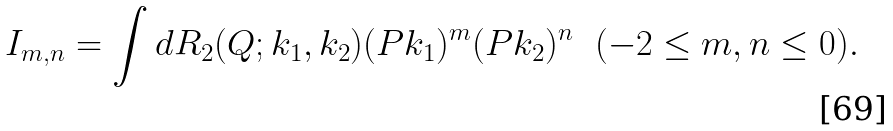Convert formula to latex. <formula><loc_0><loc_0><loc_500><loc_500>I _ { m , n } = \int d R _ { 2 } ( Q ; k _ { 1 } , k _ { 2 } ) ( P k _ { 1 } ) ^ { m } ( P k _ { 2 } ) ^ { n } \ \ ( - 2 \leq m , n \leq 0 ) .</formula> 